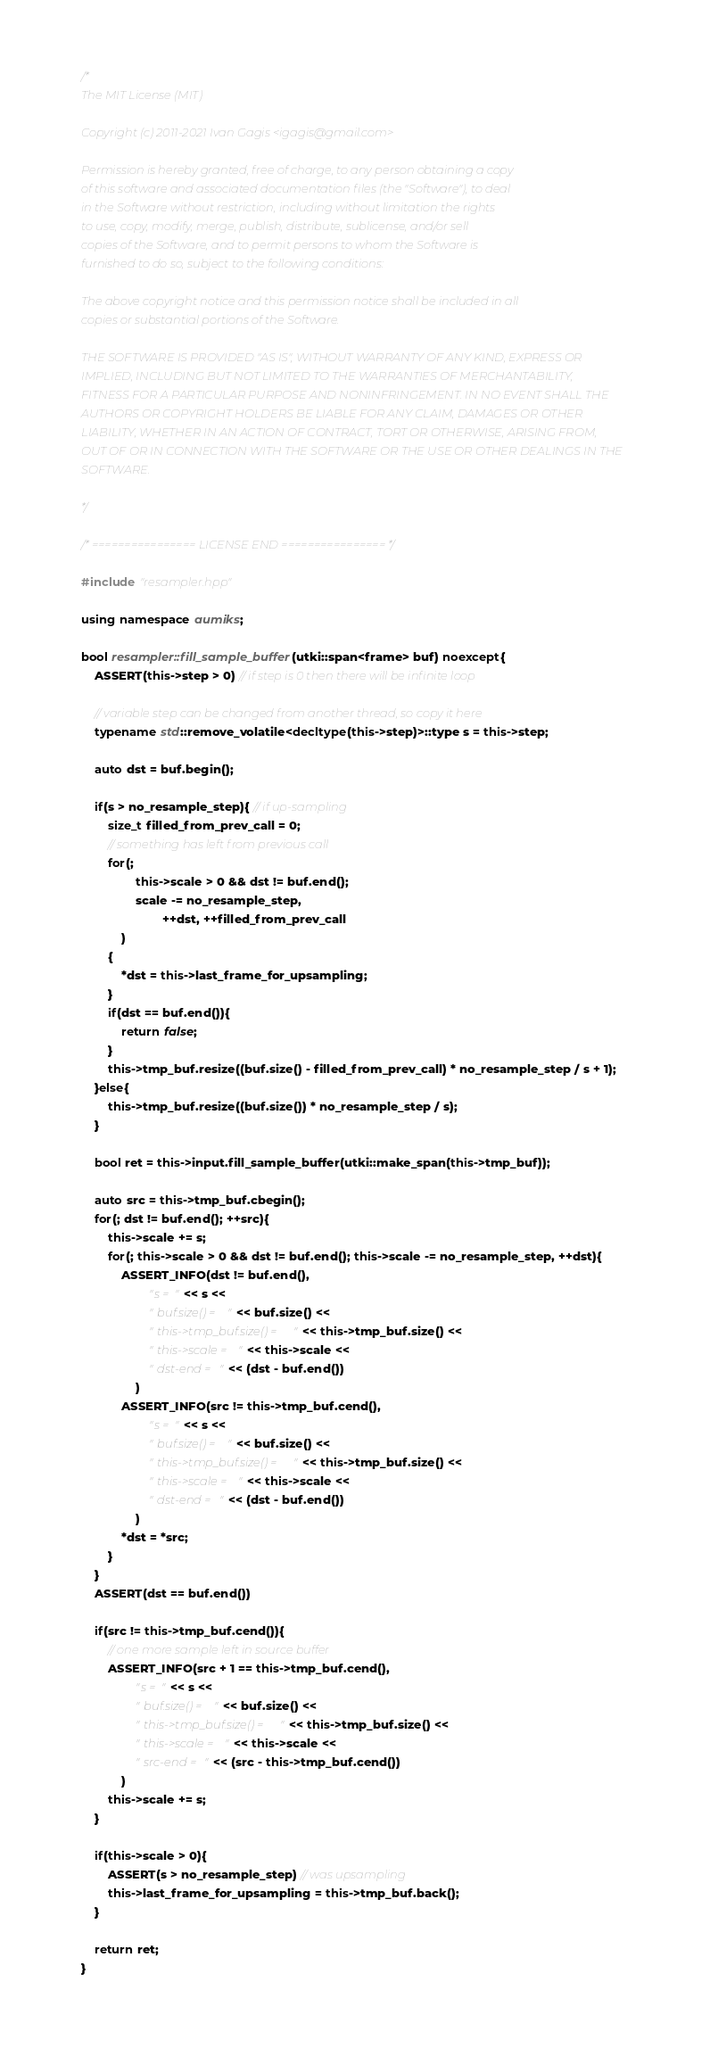Convert code to text. <code><loc_0><loc_0><loc_500><loc_500><_C++_>/*
The MIT License (MIT)

Copyright (c) 2011-2021 Ivan Gagis <igagis@gmail.com>

Permission is hereby granted, free of charge, to any person obtaining a copy
of this software and associated documentation files (the "Software"), to deal
in the Software without restriction, including without limitation the rights
to use, copy, modify, merge, publish, distribute, sublicense, and/or sell
copies of the Software, and to permit persons to whom the Software is
furnished to do so, subject to the following conditions:

The above copyright notice and this permission notice shall be included in all
copies or substantial portions of the Software.

THE SOFTWARE IS PROVIDED "AS IS", WITHOUT WARRANTY OF ANY KIND, EXPRESS OR
IMPLIED, INCLUDING BUT NOT LIMITED TO THE WARRANTIES OF MERCHANTABILITY,
FITNESS FOR A PARTICULAR PURPOSE AND NONINFRINGEMENT. IN NO EVENT SHALL THE
AUTHORS OR COPYRIGHT HOLDERS BE LIABLE FOR ANY CLAIM, DAMAGES OR OTHER
LIABILITY, WHETHER IN AN ACTION OF CONTRACT, TORT OR OTHERWISE, ARISING FROM,
OUT OF OR IN CONNECTION WITH THE SOFTWARE OR THE USE OR OTHER DEALINGS IN THE
SOFTWARE.

*/

/* ================ LICENSE END ================ */

#include "resampler.hpp"

using namespace aumiks;

bool resampler::fill_sample_buffer(utki::span<frame> buf) noexcept{
	ASSERT(this->step > 0) // if step is 0 then there will be infinite loop

	// variable step can be changed from another thread, so copy it here
	typename std::remove_volatile<decltype(this->step)>::type s = this->step;

	auto dst = buf.begin();

	if(s > no_resample_step){ // if up-sampling
		size_t filled_from_prev_call = 0;
		// something has left from previous call
		for(;
				this->scale > 0 && dst != buf.end();
				scale -= no_resample_step,
						++dst, ++filled_from_prev_call
			)
		{
			*dst = this->last_frame_for_upsampling;
		}
		if(dst == buf.end()){
			return false;
		}
		this->tmp_buf.resize((buf.size() - filled_from_prev_call) * no_resample_step / s + 1);
	}else{
		this->tmp_buf.resize((buf.size()) * no_resample_step / s);
	}

	bool ret = this->input.fill_sample_buffer(utki::make_span(this->tmp_buf));

	auto src = this->tmp_buf.cbegin();
	for(; dst != buf.end(); ++src){
		this->scale += s;
		for(; this->scale > 0 && dst != buf.end(); this->scale -= no_resample_step, ++dst){
			ASSERT_INFO(dst != buf.end(),
					"s = " << s <<
					" buf.size() = " << buf.size() <<
					" this->tmp_buf.size() = " << this->tmp_buf.size() <<
					" this->scale = " << this->scale <<
					" dst-end = " << (dst - buf.end())
				)
			ASSERT_INFO(src != this->tmp_buf.cend(),
					"s = " << s <<
					" buf.size() = " << buf.size() <<
					" this->tmp_buf.size() = " << this->tmp_buf.size() <<
					" this->scale = " << this->scale <<
					" dst-end = " << (dst - buf.end())
				)
			*dst = *src;
		}
	}
	ASSERT(dst == buf.end())

	if(src != this->tmp_buf.cend()){
		// one more sample left in source buffer
		ASSERT_INFO(src + 1 == this->tmp_buf.cend(),
				"s = " << s <<
				" buf.size() = " << buf.size() <<
				" this->tmp_buf.size() = " << this->tmp_buf.size() <<
				" this->scale = " << this->scale <<
				" src-end = " << (src - this->tmp_buf.cend())
			)
		this->scale += s;
	}

	if(this->scale > 0){
		ASSERT(s > no_resample_step) // was upsampling
		this->last_frame_for_upsampling = this->tmp_buf.back();
	}

	return ret;
}
</code> 